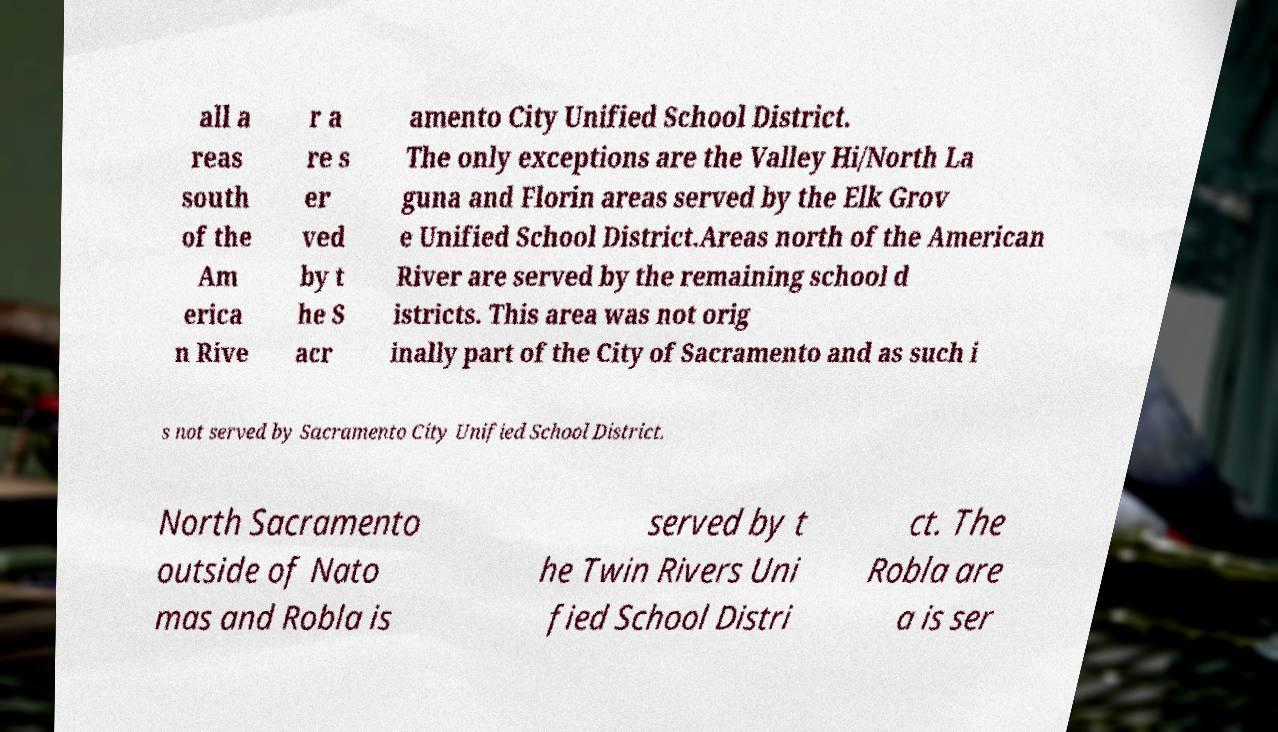For documentation purposes, I need the text within this image transcribed. Could you provide that? all a reas south of the Am erica n Rive r a re s er ved by t he S acr amento City Unified School District. The only exceptions are the Valley Hi/North La guna and Florin areas served by the Elk Grov e Unified School District.Areas north of the American River are served by the remaining school d istricts. This area was not orig inally part of the City of Sacramento and as such i s not served by Sacramento City Unified School District. North Sacramento outside of Nato mas and Robla is served by t he Twin Rivers Uni fied School Distri ct. The Robla are a is ser 